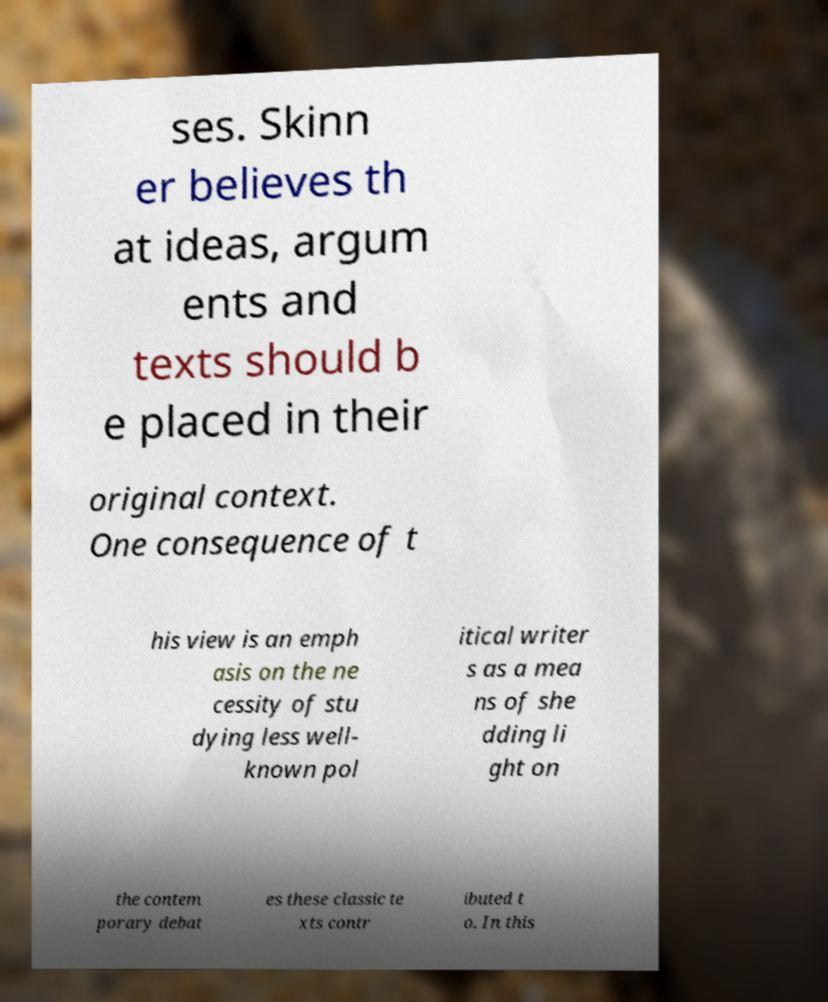Please read and relay the text visible in this image. What does it say? ses. Skinn er believes th at ideas, argum ents and texts should b e placed in their original context. One consequence of t his view is an emph asis on the ne cessity of stu dying less well- known pol itical writer s as a mea ns of she dding li ght on the contem porary debat es these classic te xts contr ibuted t o. In this 